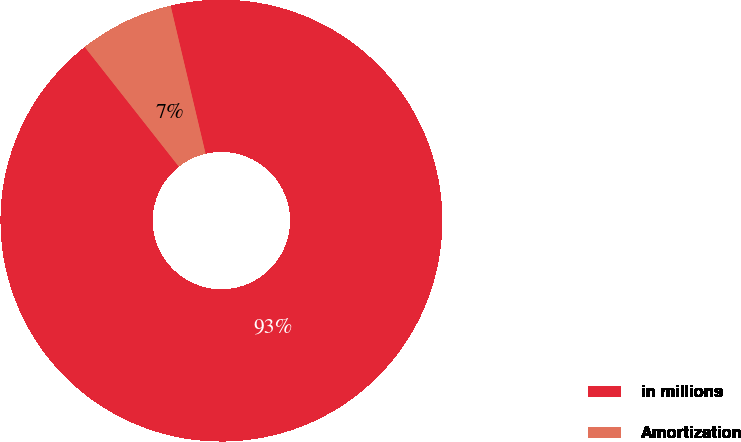Convert chart. <chart><loc_0><loc_0><loc_500><loc_500><pie_chart><fcel>in millions<fcel>Amortization<nl><fcel>93.08%<fcel>6.92%<nl></chart> 